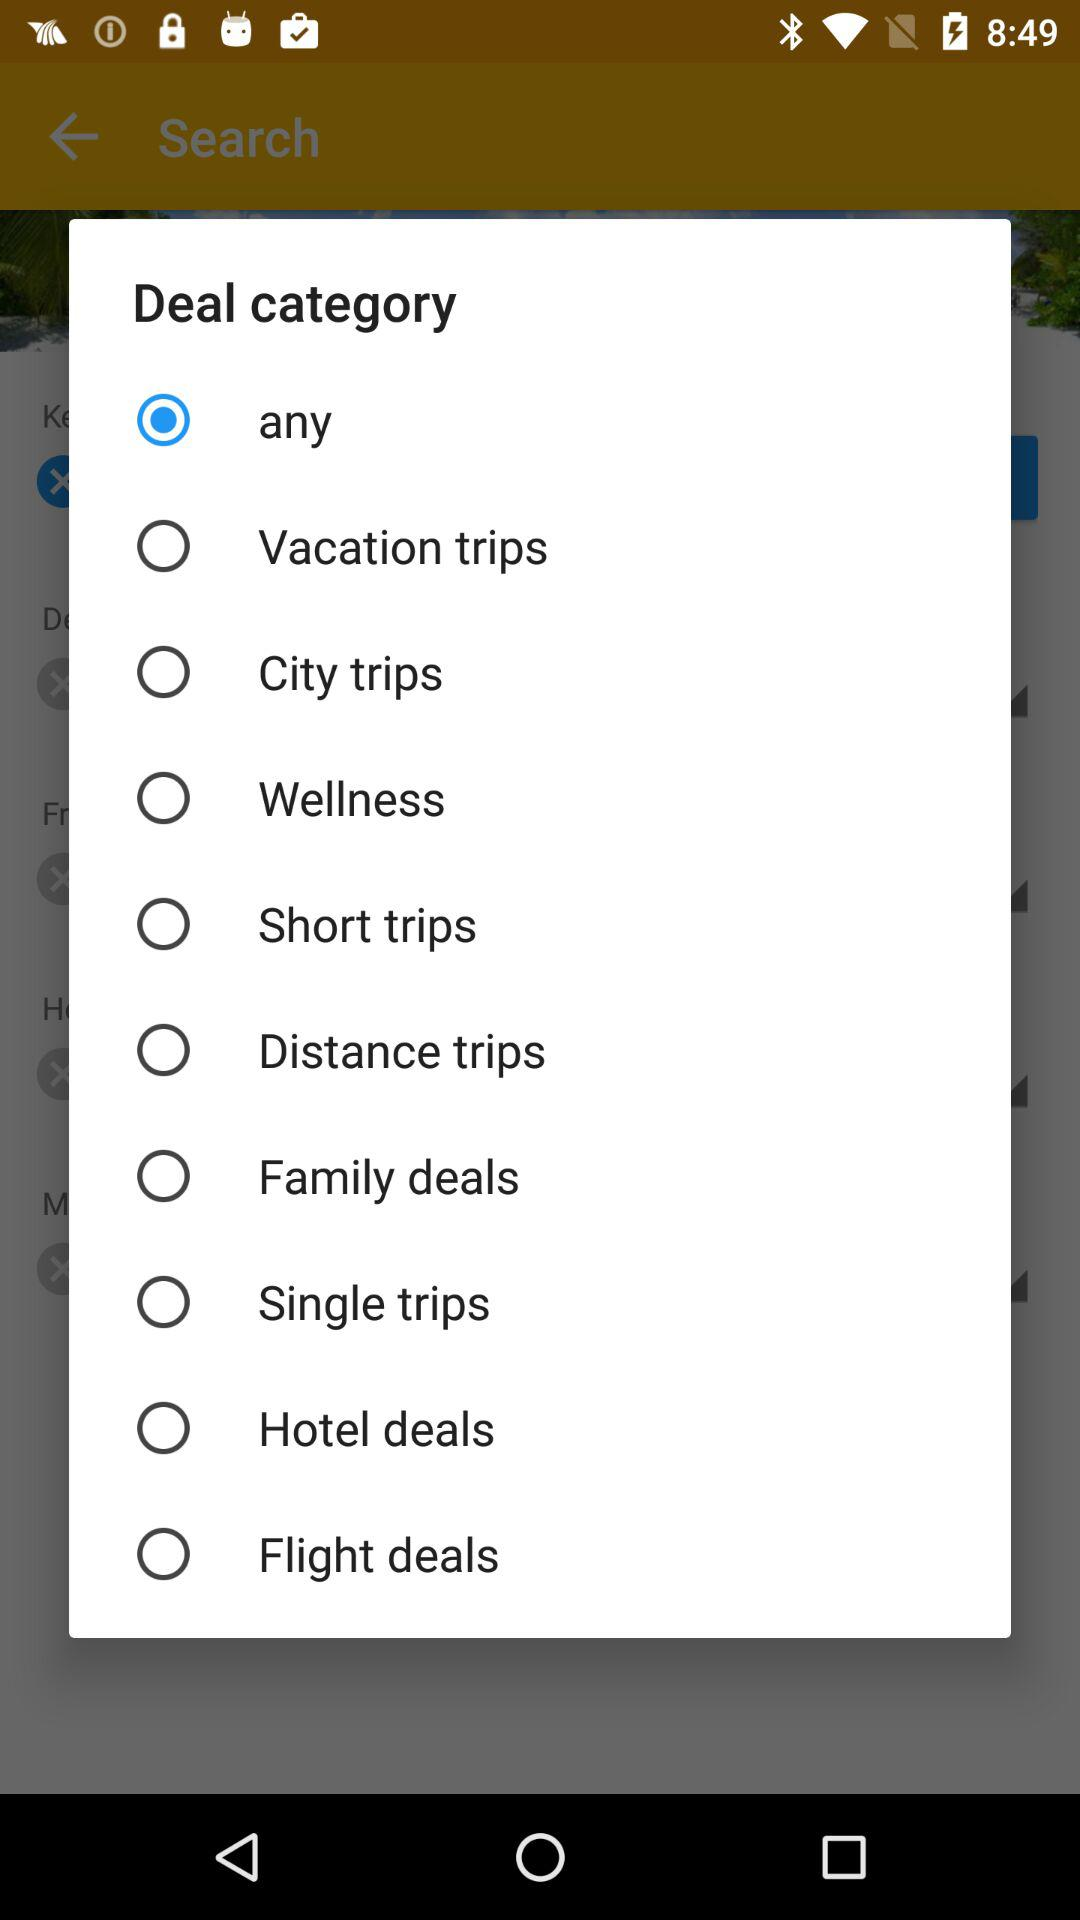Is "Short trips" selected or not? "Short trips" is not selected. 